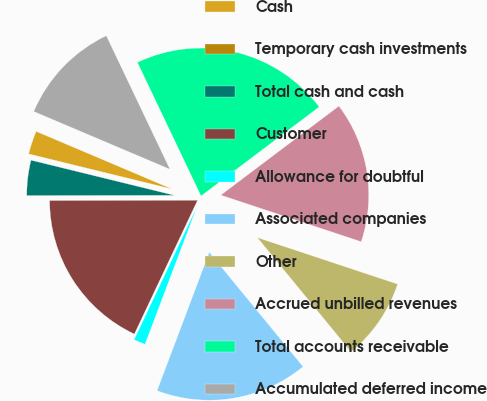<chart> <loc_0><loc_0><loc_500><loc_500><pie_chart><fcel>Cash<fcel>Temporary cash investments<fcel>Total cash and cash<fcel>Customer<fcel>Allowance for doubtful<fcel>Associated companies<fcel>Other<fcel>Accrued unbilled revenues<fcel>Total accounts receivable<fcel>Accumulated deferred income<nl><fcel>2.56%<fcel>0.0%<fcel>3.85%<fcel>17.95%<fcel>1.28%<fcel>16.67%<fcel>8.97%<fcel>15.38%<fcel>21.79%<fcel>11.54%<nl></chart> 